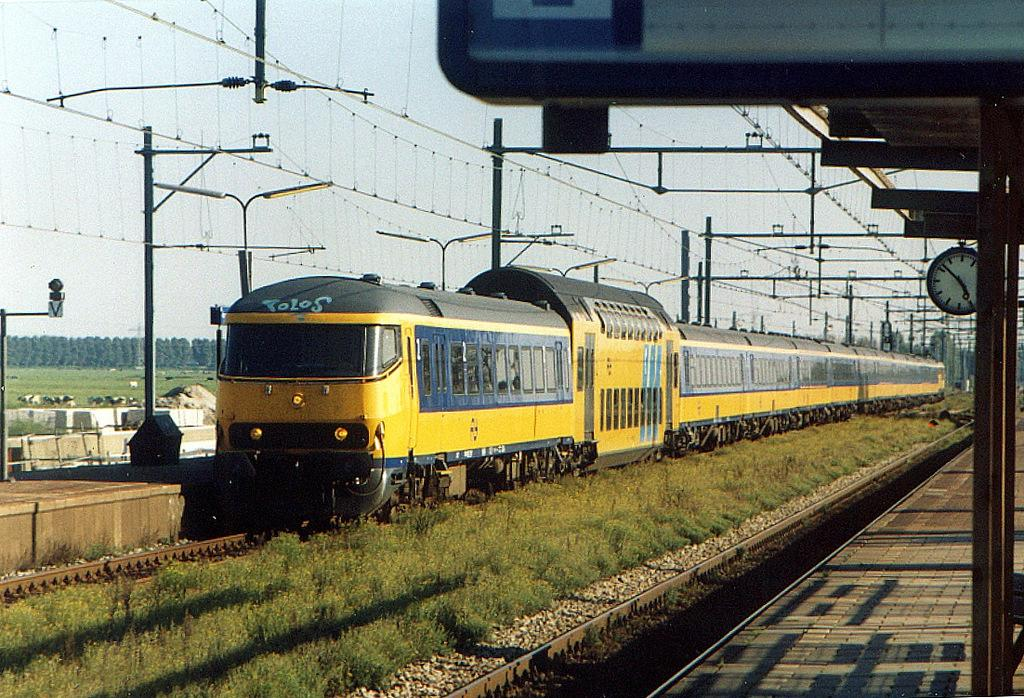<image>
Share a concise interpretation of the image provided. a train that has the word tolos at the top of it 